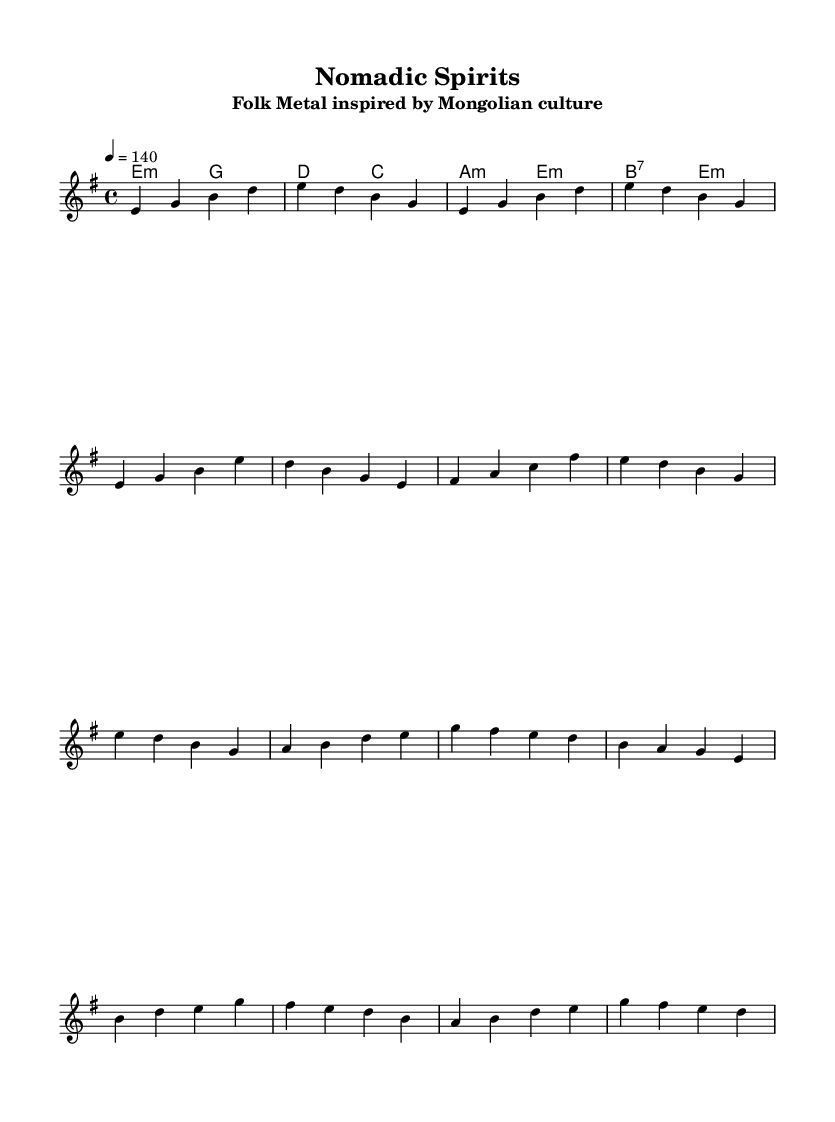What is the key signature of this music? The key signature indicates E minor, which has one sharp (F sharp). It can be identified at the beginning of the piece.
Answer: E minor What is the time signature of this music? The time signature is found at the beginning of the score, indicated by the fraction. It shows that there are four beats in each measure, with a quarter note receiving one beat.
Answer: 4/4 What is the tempo marking for this piece? The tempo marking is specified at the beginning of the score, indicating how fast the piece should be played. It shows a quarter note equals 140 beats per minute.
Answer: 140 How many measures are in the melody section? To determine the number of measures, we can count the groupings of notes divided by vertical lines. After counting all sections provided, there are a total of six measures in the melody.
Answer: 6 Which chords accompany the verse section? The harmony section outlines the chords that accompany the melody. Looking closely at the chords during the verse segment, the chords used are E minor and D major.
Answer: E minor, D major What kind of music genre is this composition? This composition is categorized as Folk Metal. This can be inferred from the melding of traditional folk melodies and metal elements like instrumentation and riffs throughout the piece.
Answer: Folk Metal What is the primary instrument implied for the melody in this sheet music? The sheet music conveys a single voice for the melody line, suggesting a lead instrument like guitar or violin, which is common in Folk Metal.
Answer: Violin 